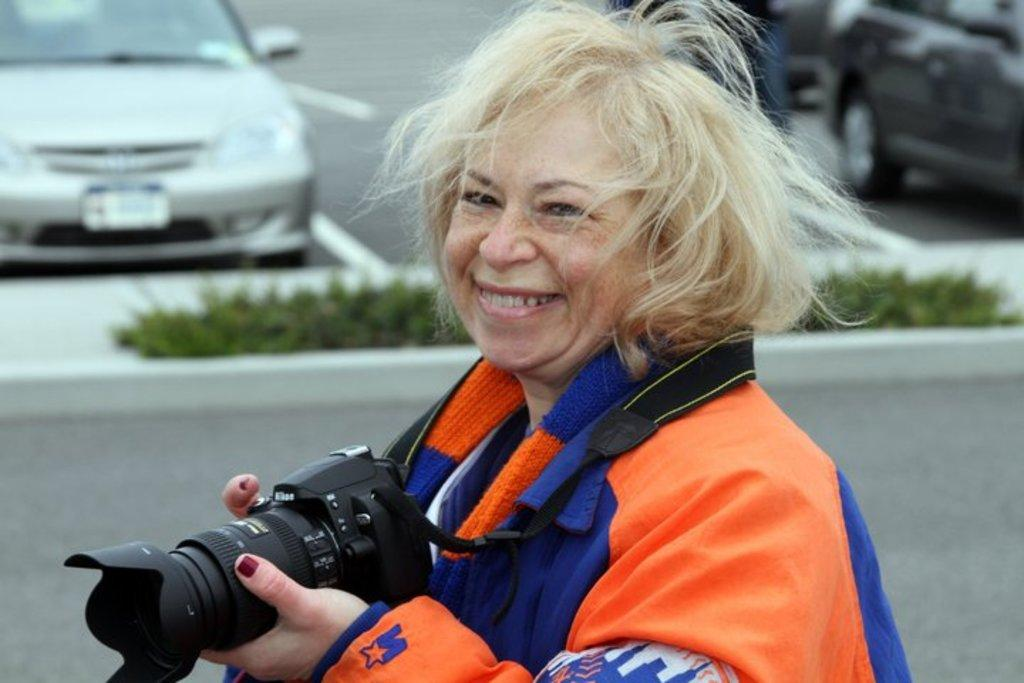Who is present in the image? There is a woman in the image. What is the woman holding in the image? The woman is holding a camera. What is the woman's facial expression in the image? The woman is smiling in the image. What can be seen on the road in the image? There is a car visible on the road in the image. What type of brass instrument is the woman playing in the image? There is no brass instrument present in the image; the woman is holding a camera. 